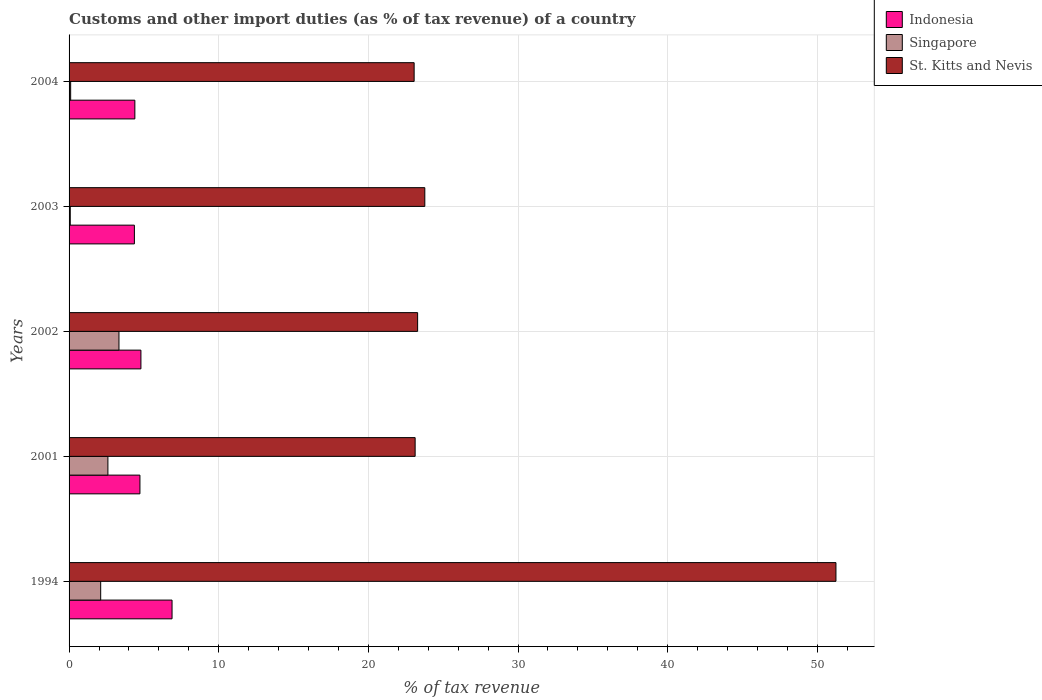How many different coloured bars are there?
Keep it short and to the point. 3. Are the number of bars on each tick of the Y-axis equal?
Make the answer very short. Yes. What is the label of the 2nd group of bars from the top?
Offer a very short reply. 2003. What is the percentage of tax revenue from customs in Indonesia in 2002?
Offer a very short reply. 4.8. Across all years, what is the maximum percentage of tax revenue from customs in St. Kitts and Nevis?
Provide a succinct answer. 51.24. Across all years, what is the minimum percentage of tax revenue from customs in St. Kitts and Nevis?
Offer a very short reply. 23.06. In which year was the percentage of tax revenue from customs in Singapore minimum?
Give a very brief answer. 2003. What is the total percentage of tax revenue from customs in Indonesia in the graph?
Provide a short and direct response. 25.18. What is the difference between the percentage of tax revenue from customs in Indonesia in 1994 and that in 2001?
Keep it short and to the point. 2.15. What is the difference between the percentage of tax revenue from customs in St. Kitts and Nevis in 1994 and the percentage of tax revenue from customs in Singapore in 2001?
Offer a terse response. 48.65. What is the average percentage of tax revenue from customs in Indonesia per year?
Make the answer very short. 5.04. In the year 2004, what is the difference between the percentage of tax revenue from customs in Indonesia and percentage of tax revenue from customs in St. Kitts and Nevis?
Make the answer very short. -18.66. What is the ratio of the percentage of tax revenue from customs in Singapore in 2003 to that in 2004?
Your answer should be very brief. 0.75. What is the difference between the highest and the second highest percentage of tax revenue from customs in St. Kitts and Nevis?
Provide a succinct answer. 27.47. What is the difference between the highest and the lowest percentage of tax revenue from customs in Singapore?
Make the answer very short. 3.25. In how many years, is the percentage of tax revenue from customs in Indonesia greater than the average percentage of tax revenue from customs in Indonesia taken over all years?
Make the answer very short. 1. Is the sum of the percentage of tax revenue from customs in Singapore in 1994 and 2004 greater than the maximum percentage of tax revenue from customs in Indonesia across all years?
Provide a short and direct response. No. What does the 2nd bar from the top in 2003 represents?
Your response must be concise. Singapore. What does the 1st bar from the bottom in 2003 represents?
Ensure brevity in your answer.  Indonesia. How many bars are there?
Your answer should be very brief. 15. How many years are there in the graph?
Provide a short and direct response. 5. What is the difference between two consecutive major ticks on the X-axis?
Make the answer very short. 10. Are the values on the major ticks of X-axis written in scientific E-notation?
Give a very brief answer. No. Does the graph contain any zero values?
Make the answer very short. No. Does the graph contain grids?
Offer a very short reply. Yes. How are the legend labels stacked?
Ensure brevity in your answer.  Vertical. What is the title of the graph?
Offer a terse response. Customs and other import duties (as % of tax revenue) of a country. Does "High income: nonOECD" appear as one of the legend labels in the graph?
Offer a terse response. No. What is the label or title of the X-axis?
Keep it short and to the point. % of tax revenue. What is the label or title of the Y-axis?
Make the answer very short. Years. What is the % of tax revenue in Indonesia in 1994?
Provide a succinct answer. 6.88. What is the % of tax revenue in Singapore in 1994?
Provide a succinct answer. 2.11. What is the % of tax revenue in St. Kitts and Nevis in 1994?
Give a very brief answer. 51.24. What is the % of tax revenue in Indonesia in 2001?
Offer a terse response. 4.74. What is the % of tax revenue in Singapore in 2001?
Provide a succinct answer. 2.6. What is the % of tax revenue of St. Kitts and Nevis in 2001?
Your answer should be very brief. 23.12. What is the % of tax revenue in Indonesia in 2002?
Your answer should be very brief. 4.8. What is the % of tax revenue in Singapore in 2002?
Keep it short and to the point. 3.33. What is the % of tax revenue of St. Kitts and Nevis in 2002?
Your answer should be compact. 23.29. What is the % of tax revenue in Indonesia in 2003?
Ensure brevity in your answer.  4.36. What is the % of tax revenue of Singapore in 2003?
Your response must be concise. 0.08. What is the % of tax revenue in St. Kitts and Nevis in 2003?
Provide a succinct answer. 23.77. What is the % of tax revenue in Indonesia in 2004?
Make the answer very short. 4.4. What is the % of tax revenue of Singapore in 2004?
Make the answer very short. 0.11. What is the % of tax revenue of St. Kitts and Nevis in 2004?
Ensure brevity in your answer.  23.06. Across all years, what is the maximum % of tax revenue in Indonesia?
Offer a terse response. 6.88. Across all years, what is the maximum % of tax revenue in Singapore?
Make the answer very short. 3.33. Across all years, what is the maximum % of tax revenue in St. Kitts and Nevis?
Ensure brevity in your answer.  51.24. Across all years, what is the minimum % of tax revenue of Indonesia?
Ensure brevity in your answer.  4.36. Across all years, what is the minimum % of tax revenue of Singapore?
Your answer should be compact. 0.08. Across all years, what is the minimum % of tax revenue of St. Kitts and Nevis?
Your answer should be compact. 23.06. What is the total % of tax revenue in Indonesia in the graph?
Provide a succinct answer. 25.18. What is the total % of tax revenue of Singapore in the graph?
Give a very brief answer. 8.23. What is the total % of tax revenue in St. Kitts and Nevis in the graph?
Offer a very short reply. 144.49. What is the difference between the % of tax revenue of Indonesia in 1994 and that in 2001?
Provide a succinct answer. 2.15. What is the difference between the % of tax revenue of Singapore in 1994 and that in 2001?
Offer a terse response. -0.48. What is the difference between the % of tax revenue of St. Kitts and Nevis in 1994 and that in 2001?
Ensure brevity in your answer.  28.12. What is the difference between the % of tax revenue in Indonesia in 1994 and that in 2002?
Provide a short and direct response. 2.08. What is the difference between the % of tax revenue of Singapore in 1994 and that in 2002?
Offer a terse response. -1.22. What is the difference between the % of tax revenue of St. Kitts and Nevis in 1994 and that in 2002?
Make the answer very short. 27.95. What is the difference between the % of tax revenue in Indonesia in 1994 and that in 2003?
Your answer should be very brief. 2.52. What is the difference between the % of tax revenue in Singapore in 1994 and that in 2003?
Offer a very short reply. 2.03. What is the difference between the % of tax revenue in St. Kitts and Nevis in 1994 and that in 2003?
Provide a succinct answer. 27.47. What is the difference between the % of tax revenue in Indonesia in 1994 and that in 2004?
Provide a short and direct response. 2.49. What is the difference between the % of tax revenue of Singapore in 1994 and that in 2004?
Provide a succinct answer. 2.01. What is the difference between the % of tax revenue in St. Kitts and Nevis in 1994 and that in 2004?
Your answer should be compact. 28.18. What is the difference between the % of tax revenue of Indonesia in 2001 and that in 2002?
Your answer should be compact. -0.07. What is the difference between the % of tax revenue of Singapore in 2001 and that in 2002?
Make the answer very short. -0.74. What is the difference between the % of tax revenue of St. Kitts and Nevis in 2001 and that in 2002?
Offer a very short reply. -0.17. What is the difference between the % of tax revenue in Indonesia in 2001 and that in 2003?
Your answer should be compact. 0.37. What is the difference between the % of tax revenue of Singapore in 2001 and that in 2003?
Give a very brief answer. 2.52. What is the difference between the % of tax revenue of St. Kitts and Nevis in 2001 and that in 2003?
Give a very brief answer. -0.65. What is the difference between the % of tax revenue of Indonesia in 2001 and that in 2004?
Provide a succinct answer. 0.34. What is the difference between the % of tax revenue of Singapore in 2001 and that in 2004?
Ensure brevity in your answer.  2.49. What is the difference between the % of tax revenue of St. Kitts and Nevis in 2001 and that in 2004?
Keep it short and to the point. 0.07. What is the difference between the % of tax revenue in Indonesia in 2002 and that in 2003?
Provide a short and direct response. 0.44. What is the difference between the % of tax revenue in Singapore in 2002 and that in 2003?
Offer a terse response. 3.25. What is the difference between the % of tax revenue of St. Kitts and Nevis in 2002 and that in 2003?
Your response must be concise. -0.48. What is the difference between the % of tax revenue in Indonesia in 2002 and that in 2004?
Keep it short and to the point. 0.41. What is the difference between the % of tax revenue of Singapore in 2002 and that in 2004?
Offer a terse response. 3.23. What is the difference between the % of tax revenue of St. Kitts and Nevis in 2002 and that in 2004?
Provide a short and direct response. 0.23. What is the difference between the % of tax revenue of Indonesia in 2003 and that in 2004?
Give a very brief answer. -0.03. What is the difference between the % of tax revenue of Singapore in 2003 and that in 2004?
Make the answer very short. -0.03. What is the difference between the % of tax revenue in St. Kitts and Nevis in 2003 and that in 2004?
Give a very brief answer. 0.71. What is the difference between the % of tax revenue in Indonesia in 1994 and the % of tax revenue in Singapore in 2001?
Offer a very short reply. 4.29. What is the difference between the % of tax revenue of Indonesia in 1994 and the % of tax revenue of St. Kitts and Nevis in 2001?
Keep it short and to the point. -16.24. What is the difference between the % of tax revenue of Singapore in 1994 and the % of tax revenue of St. Kitts and Nevis in 2001?
Keep it short and to the point. -21.01. What is the difference between the % of tax revenue of Indonesia in 1994 and the % of tax revenue of Singapore in 2002?
Your answer should be very brief. 3.55. What is the difference between the % of tax revenue in Indonesia in 1994 and the % of tax revenue in St. Kitts and Nevis in 2002?
Ensure brevity in your answer.  -16.41. What is the difference between the % of tax revenue of Singapore in 1994 and the % of tax revenue of St. Kitts and Nevis in 2002?
Provide a short and direct response. -21.18. What is the difference between the % of tax revenue in Indonesia in 1994 and the % of tax revenue in Singapore in 2003?
Make the answer very short. 6.8. What is the difference between the % of tax revenue of Indonesia in 1994 and the % of tax revenue of St. Kitts and Nevis in 2003?
Provide a succinct answer. -16.89. What is the difference between the % of tax revenue in Singapore in 1994 and the % of tax revenue in St. Kitts and Nevis in 2003?
Your answer should be compact. -21.66. What is the difference between the % of tax revenue of Indonesia in 1994 and the % of tax revenue of Singapore in 2004?
Keep it short and to the point. 6.77. What is the difference between the % of tax revenue of Indonesia in 1994 and the % of tax revenue of St. Kitts and Nevis in 2004?
Ensure brevity in your answer.  -16.18. What is the difference between the % of tax revenue in Singapore in 1994 and the % of tax revenue in St. Kitts and Nevis in 2004?
Keep it short and to the point. -20.95. What is the difference between the % of tax revenue in Indonesia in 2001 and the % of tax revenue in Singapore in 2002?
Your answer should be compact. 1.4. What is the difference between the % of tax revenue in Indonesia in 2001 and the % of tax revenue in St. Kitts and Nevis in 2002?
Your response must be concise. -18.56. What is the difference between the % of tax revenue of Singapore in 2001 and the % of tax revenue of St. Kitts and Nevis in 2002?
Ensure brevity in your answer.  -20.7. What is the difference between the % of tax revenue in Indonesia in 2001 and the % of tax revenue in Singapore in 2003?
Make the answer very short. 4.65. What is the difference between the % of tax revenue in Indonesia in 2001 and the % of tax revenue in St. Kitts and Nevis in 2003?
Provide a succinct answer. -19.04. What is the difference between the % of tax revenue of Singapore in 2001 and the % of tax revenue of St. Kitts and Nevis in 2003?
Offer a terse response. -21.18. What is the difference between the % of tax revenue in Indonesia in 2001 and the % of tax revenue in Singapore in 2004?
Your response must be concise. 4.63. What is the difference between the % of tax revenue in Indonesia in 2001 and the % of tax revenue in St. Kitts and Nevis in 2004?
Make the answer very short. -18.32. What is the difference between the % of tax revenue in Singapore in 2001 and the % of tax revenue in St. Kitts and Nevis in 2004?
Your response must be concise. -20.46. What is the difference between the % of tax revenue of Indonesia in 2002 and the % of tax revenue of Singapore in 2003?
Provide a succinct answer. 4.72. What is the difference between the % of tax revenue in Indonesia in 2002 and the % of tax revenue in St. Kitts and Nevis in 2003?
Offer a very short reply. -18.97. What is the difference between the % of tax revenue in Singapore in 2002 and the % of tax revenue in St. Kitts and Nevis in 2003?
Your answer should be very brief. -20.44. What is the difference between the % of tax revenue in Indonesia in 2002 and the % of tax revenue in Singapore in 2004?
Give a very brief answer. 4.69. What is the difference between the % of tax revenue of Indonesia in 2002 and the % of tax revenue of St. Kitts and Nevis in 2004?
Ensure brevity in your answer.  -18.26. What is the difference between the % of tax revenue of Singapore in 2002 and the % of tax revenue of St. Kitts and Nevis in 2004?
Provide a short and direct response. -19.72. What is the difference between the % of tax revenue in Indonesia in 2003 and the % of tax revenue in Singapore in 2004?
Offer a very short reply. 4.26. What is the difference between the % of tax revenue in Indonesia in 2003 and the % of tax revenue in St. Kitts and Nevis in 2004?
Your answer should be compact. -18.69. What is the difference between the % of tax revenue in Singapore in 2003 and the % of tax revenue in St. Kitts and Nevis in 2004?
Ensure brevity in your answer.  -22.98. What is the average % of tax revenue of Indonesia per year?
Your response must be concise. 5.04. What is the average % of tax revenue of Singapore per year?
Offer a terse response. 1.65. What is the average % of tax revenue of St. Kitts and Nevis per year?
Make the answer very short. 28.9. In the year 1994, what is the difference between the % of tax revenue in Indonesia and % of tax revenue in Singapore?
Your answer should be compact. 4.77. In the year 1994, what is the difference between the % of tax revenue of Indonesia and % of tax revenue of St. Kitts and Nevis?
Provide a succinct answer. -44.36. In the year 1994, what is the difference between the % of tax revenue of Singapore and % of tax revenue of St. Kitts and Nevis?
Provide a short and direct response. -49.13. In the year 2001, what is the difference between the % of tax revenue of Indonesia and % of tax revenue of Singapore?
Your answer should be compact. 2.14. In the year 2001, what is the difference between the % of tax revenue of Indonesia and % of tax revenue of St. Kitts and Nevis?
Ensure brevity in your answer.  -18.39. In the year 2001, what is the difference between the % of tax revenue in Singapore and % of tax revenue in St. Kitts and Nevis?
Ensure brevity in your answer.  -20.53. In the year 2002, what is the difference between the % of tax revenue in Indonesia and % of tax revenue in Singapore?
Ensure brevity in your answer.  1.47. In the year 2002, what is the difference between the % of tax revenue in Indonesia and % of tax revenue in St. Kitts and Nevis?
Provide a short and direct response. -18.49. In the year 2002, what is the difference between the % of tax revenue of Singapore and % of tax revenue of St. Kitts and Nevis?
Provide a succinct answer. -19.96. In the year 2003, what is the difference between the % of tax revenue in Indonesia and % of tax revenue in Singapore?
Your answer should be very brief. 4.28. In the year 2003, what is the difference between the % of tax revenue in Indonesia and % of tax revenue in St. Kitts and Nevis?
Your response must be concise. -19.41. In the year 2003, what is the difference between the % of tax revenue in Singapore and % of tax revenue in St. Kitts and Nevis?
Offer a very short reply. -23.69. In the year 2004, what is the difference between the % of tax revenue of Indonesia and % of tax revenue of Singapore?
Offer a very short reply. 4.29. In the year 2004, what is the difference between the % of tax revenue of Indonesia and % of tax revenue of St. Kitts and Nevis?
Your answer should be compact. -18.66. In the year 2004, what is the difference between the % of tax revenue in Singapore and % of tax revenue in St. Kitts and Nevis?
Keep it short and to the point. -22.95. What is the ratio of the % of tax revenue in Indonesia in 1994 to that in 2001?
Keep it short and to the point. 1.45. What is the ratio of the % of tax revenue in Singapore in 1994 to that in 2001?
Provide a succinct answer. 0.81. What is the ratio of the % of tax revenue in St. Kitts and Nevis in 1994 to that in 2001?
Make the answer very short. 2.22. What is the ratio of the % of tax revenue in Indonesia in 1994 to that in 2002?
Provide a short and direct response. 1.43. What is the ratio of the % of tax revenue of Singapore in 1994 to that in 2002?
Provide a short and direct response. 0.63. What is the ratio of the % of tax revenue of St. Kitts and Nevis in 1994 to that in 2002?
Give a very brief answer. 2.2. What is the ratio of the % of tax revenue in Indonesia in 1994 to that in 2003?
Provide a short and direct response. 1.58. What is the ratio of the % of tax revenue of Singapore in 1994 to that in 2003?
Your answer should be compact. 26.31. What is the ratio of the % of tax revenue in St. Kitts and Nevis in 1994 to that in 2003?
Provide a succinct answer. 2.16. What is the ratio of the % of tax revenue of Indonesia in 1994 to that in 2004?
Keep it short and to the point. 1.57. What is the ratio of the % of tax revenue in Singapore in 1994 to that in 2004?
Keep it short and to the point. 19.86. What is the ratio of the % of tax revenue of St. Kitts and Nevis in 1994 to that in 2004?
Your answer should be compact. 2.22. What is the ratio of the % of tax revenue in Indonesia in 2001 to that in 2002?
Offer a terse response. 0.99. What is the ratio of the % of tax revenue in Singapore in 2001 to that in 2002?
Your answer should be very brief. 0.78. What is the ratio of the % of tax revenue of St. Kitts and Nevis in 2001 to that in 2002?
Offer a terse response. 0.99. What is the ratio of the % of tax revenue in Indonesia in 2001 to that in 2003?
Your answer should be very brief. 1.08. What is the ratio of the % of tax revenue in Singapore in 2001 to that in 2003?
Provide a short and direct response. 32.32. What is the ratio of the % of tax revenue of St. Kitts and Nevis in 2001 to that in 2003?
Your response must be concise. 0.97. What is the ratio of the % of tax revenue in Indonesia in 2001 to that in 2004?
Provide a short and direct response. 1.08. What is the ratio of the % of tax revenue of Singapore in 2001 to that in 2004?
Your response must be concise. 24.4. What is the ratio of the % of tax revenue in St. Kitts and Nevis in 2001 to that in 2004?
Make the answer very short. 1. What is the ratio of the % of tax revenue in Indonesia in 2002 to that in 2003?
Make the answer very short. 1.1. What is the ratio of the % of tax revenue of Singapore in 2002 to that in 2003?
Make the answer very short. 41.53. What is the ratio of the % of tax revenue in St. Kitts and Nevis in 2002 to that in 2003?
Your response must be concise. 0.98. What is the ratio of the % of tax revenue in Indonesia in 2002 to that in 2004?
Your answer should be compact. 1.09. What is the ratio of the % of tax revenue in Singapore in 2002 to that in 2004?
Keep it short and to the point. 31.34. What is the ratio of the % of tax revenue in St. Kitts and Nevis in 2002 to that in 2004?
Keep it short and to the point. 1.01. What is the ratio of the % of tax revenue in Singapore in 2003 to that in 2004?
Offer a very short reply. 0.75. What is the ratio of the % of tax revenue of St. Kitts and Nevis in 2003 to that in 2004?
Provide a succinct answer. 1.03. What is the difference between the highest and the second highest % of tax revenue in Indonesia?
Your answer should be compact. 2.08. What is the difference between the highest and the second highest % of tax revenue in Singapore?
Offer a terse response. 0.74. What is the difference between the highest and the second highest % of tax revenue of St. Kitts and Nevis?
Give a very brief answer. 27.47. What is the difference between the highest and the lowest % of tax revenue of Indonesia?
Provide a short and direct response. 2.52. What is the difference between the highest and the lowest % of tax revenue of Singapore?
Provide a short and direct response. 3.25. What is the difference between the highest and the lowest % of tax revenue of St. Kitts and Nevis?
Ensure brevity in your answer.  28.18. 